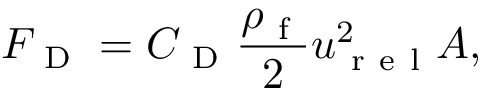<formula> <loc_0><loc_0><loc_500><loc_500>F _ { D } = C _ { D } \frac { \rho _ { f } } { 2 } u _ { r e l } ^ { 2 } A ,</formula> 